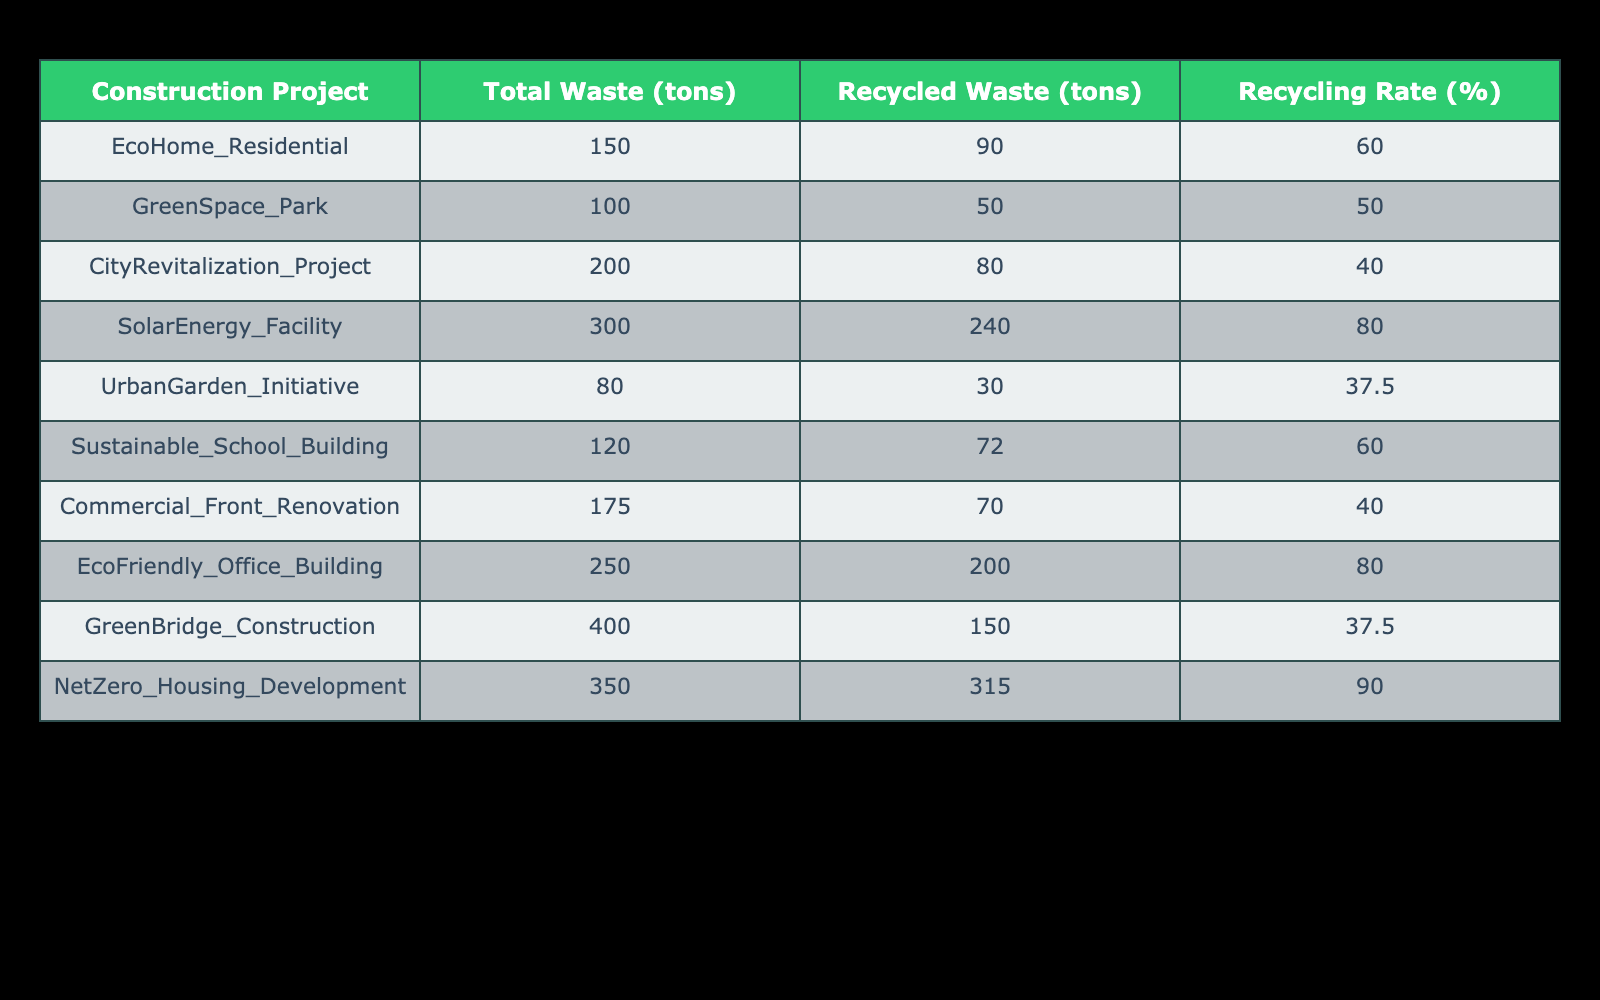What is the total waste generated by the SolarEnergy Facility? The SolarEnergy Facility's total waste generated is directly listed in the table under the total waste column. It shows 300 tons.
Answer: 300 tons Which construction project has the highest recycling rate? By looking at the recycling rate percentages for each project, the highest value is found in NetZero_Housing_Development at 90%.
Answer: NetZero_Housing_Development What is the recycling rate of the EcoHome_Residential project? The recycling rate for EcoHome_Residential is provided in the table, showing a recycling rate of 60%.
Answer: 60% Calculate the total recycled waste for all projects combined. To find the total recycled waste, I sum up the recycled waste from all projects: 90 + 50 + 80 + 240 + 30 + 72 + 70 + 200 + 150 + 315 = 1297 tons.
Answer: 1297 tons Is the recycling rate of the Commercial Front Renovation project above 50%? The recycling rate for the Commercial Front Renovation project stands at 40%, which is below 50%.
Answer: No Which project had less than 100 tons of waste generated? Looking through the total waste generated column, both EcoHome_Residential (150 tons) and Sustainable_School_Building (120 tons) exceed 100 tons; only UrbanGarden_Initiative fits under this threshold with 80 tons.
Answer: UrbanGarden_Initiative How much more waste was generated by GreenBridge_Construction compared to GreenSpace_Park? The waste generated by GreenBridge_Construction is 400 tons and by GreenSpace_Park it's 100 tons. The difference is 400 - 100 = 300 tons more.
Answer: 300 tons What percentage of the total waste generated by the EcoFriendly_Office_Building was recycled? The table indicates that the EcoFriendly_Office_Building generated 250 tons of waste, and 200 tons of it was recycled. The recycling rate is calculated as (200 / 250) * 100 = 80%.
Answer: 80% For projects with a recycling rate below 50%, how many tons of waste were generated in total? The projects with recycling rates below 50% are CityRevitalization_Project (200 tons), UrbanGarden_Initiative (80 tons), and GreenBridge_Construction (400 tons). Their combined total is 200 + 80 + 400 = 680 tons.
Answer: 680 tons 